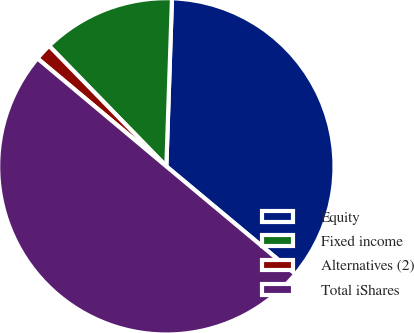<chart> <loc_0><loc_0><loc_500><loc_500><pie_chart><fcel>Equity<fcel>Fixed income<fcel>Alternatives (2)<fcel>Total iShares<nl><fcel>35.54%<fcel>12.82%<fcel>1.62%<fcel>50.03%<nl></chart> 